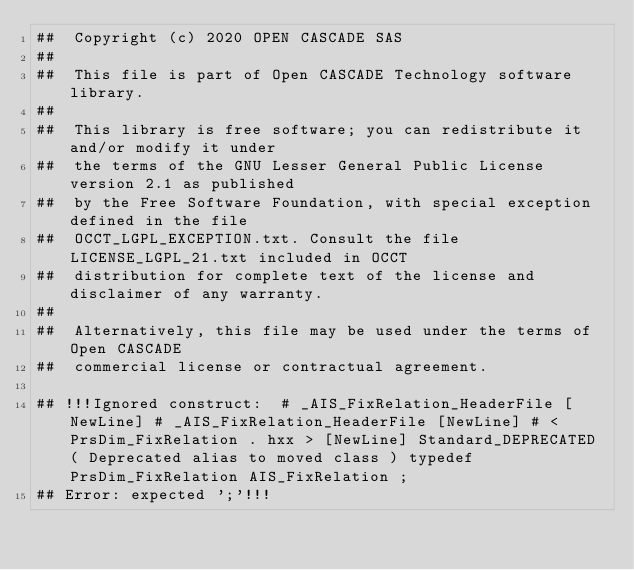<code> <loc_0><loc_0><loc_500><loc_500><_Nim_>##  Copyright (c) 2020 OPEN CASCADE SAS
##
##  This file is part of Open CASCADE Technology software library.
##
##  This library is free software; you can redistribute it and/or modify it under
##  the terms of the GNU Lesser General Public License version 2.1 as published
##  by the Free Software Foundation, with special exception defined in the file
##  OCCT_LGPL_EXCEPTION.txt. Consult the file LICENSE_LGPL_21.txt included in OCCT
##  distribution for complete text of the license and disclaimer of any warranty.
##
##  Alternatively, this file may be used under the terms of Open CASCADE
##  commercial license or contractual agreement.

## !!!Ignored construct:  # _AIS_FixRelation_HeaderFile [NewLine] # _AIS_FixRelation_HeaderFile [NewLine] # < PrsDim_FixRelation . hxx > [NewLine] Standard_DEPRECATED ( Deprecated alias to moved class ) typedef PrsDim_FixRelation AIS_FixRelation ;
## Error: expected ';'!!!














































</code> 